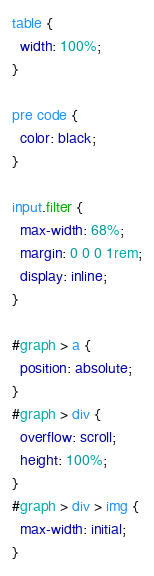<code> <loc_0><loc_0><loc_500><loc_500><_CSS_>table {
  width: 100%;
}

pre code {
  color: black;
}

input.filter {
  max-width: 68%;
  margin: 0 0 0 1rem;
  display: inline;
}

#graph > a {
  position: absolute;
}
#graph > div {
  overflow: scroll;
  height: 100%;
}
#graph > div > img {
  max-width: initial;
}
</code> 